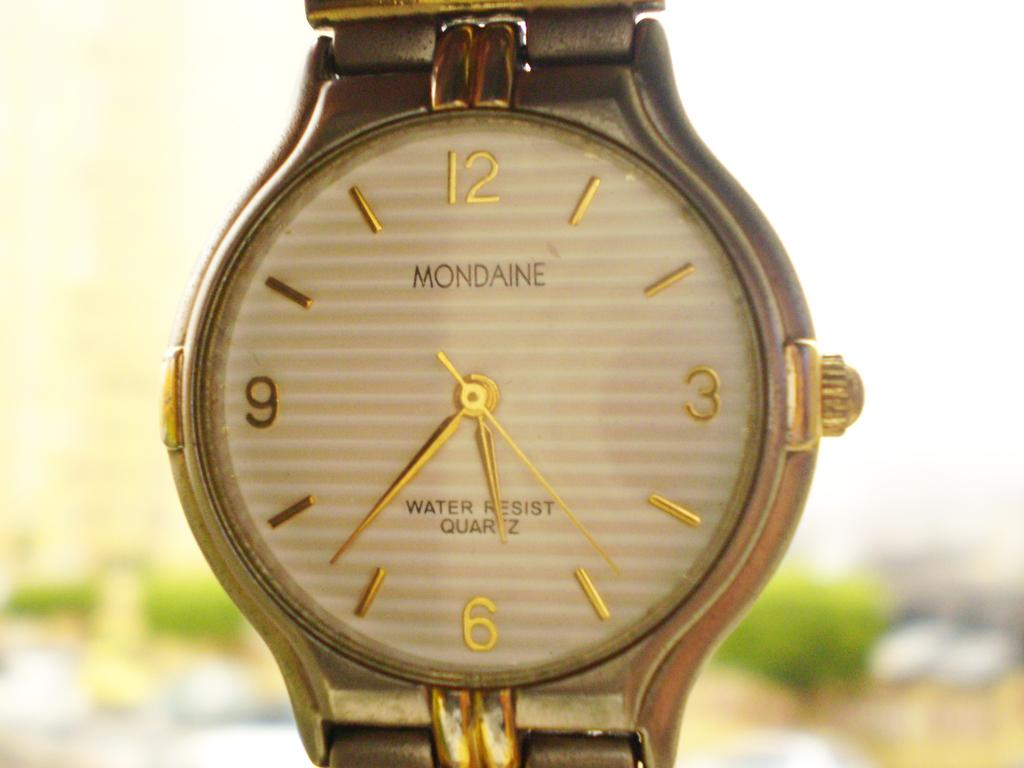<image>
Describe the image concisely. A Mondaine watch says it is water resistant and has a quartz movement. 